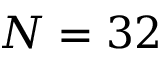<formula> <loc_0><loc_0><loc_500><loc_500>N = 3 2</formula> 